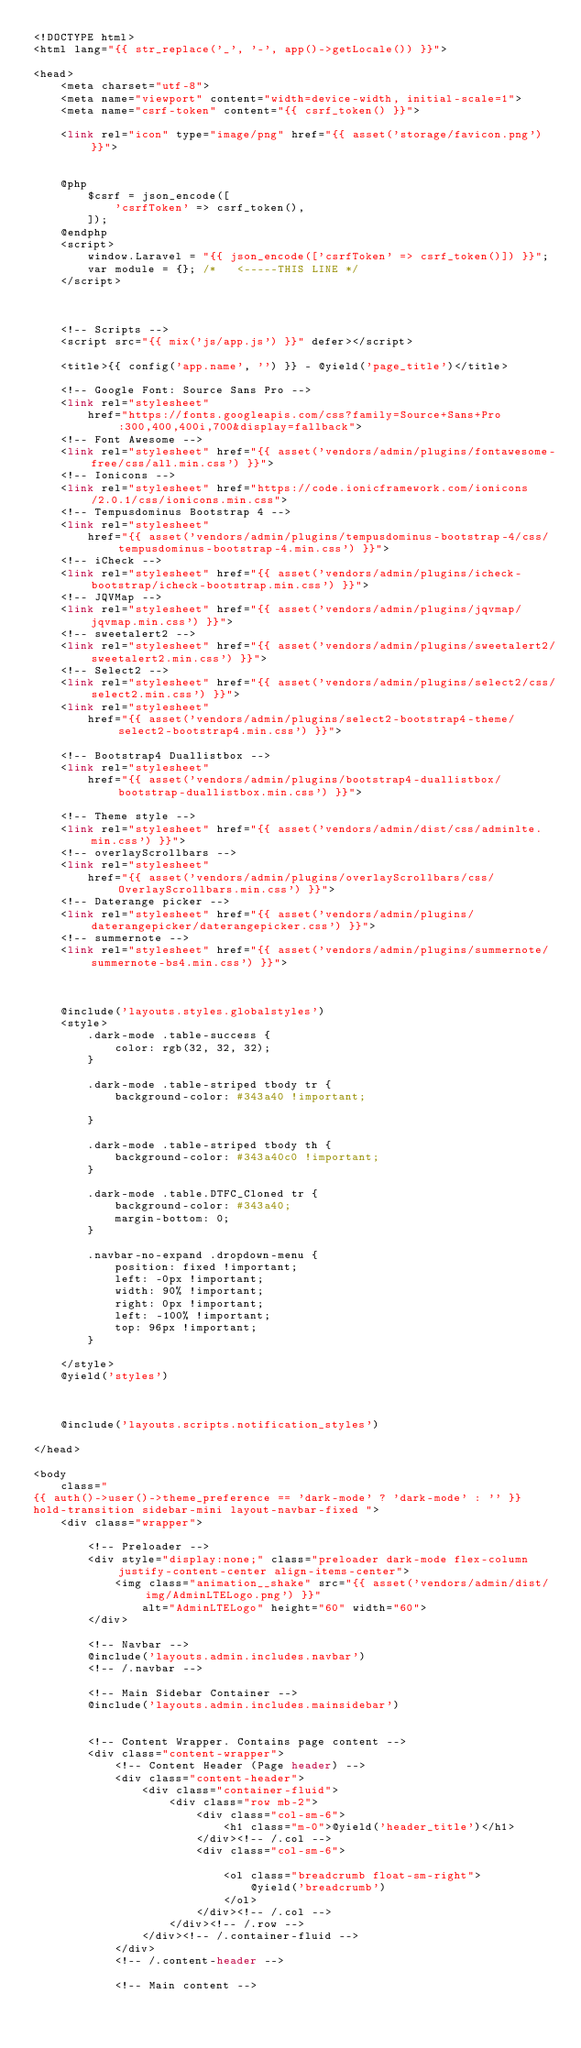Convert code to text. <code><loc_0><loc_0><loc_500><loc_500><_PHP_><!DOCTYPE html>
<html lang="{{ str_replace('_', '-', app()->getLocale()) }}">

<head>
    <meta charset="utf-8">
    <meta name="viewport" content="width=device-width, initial-scale=1">
    <meta name="csrf-token" content="{{ csrf_token() }}">

    <link rel="icon" type="image/png" href="{{ asset('storage/favicon.png') }}">


    @php
        $csrf = json_encode([
            'csrfToken' => csrf_token(),
        ]);
    @endphp
    <script>
        window.Laravel = "{{ json_encode(['csrfToken' => csrf_token()]) }}";
        var module = {}; /*   <-----THIS LINE */
    </script>



    <!-- Scripts -->
    <script src="{{ mix('js/app.js') }}" defer></script>

    <title>{{ config('app.name', '') }} - @yield('page_title')</title>

    <!-- Google Font: Source Sans Pro -->
    <link rel="stylesheet"
        href="https://fonts.googleapis.com/css?family=Source+Sans+Pro:300,400,400i,700&display=fallback">
    <!-- Font Awesome -->
    <link rel="stylesheet" href="{{ asset('vendors/admin/plugins/fontawesome-free/css/all.min.css') }}">
    <!-- Ionicons -->
    <link rel="stylesheet" href="https://code.ionicframework.com/ionicons/2.0.1/css/ionicons.min.css">
    <!-- Tempusdominus Bootstrap 4 -->
    <link rel="stylesheet"
        href="{{ asset('vendors/admin/plugins/tempusdominus-bootstrap-4/css/tempusdominus-bootstrap-4.min.css') }}">
    <!-- iCheck -->
    <link rel="stylesheet" href="{{ asset('vendors/admin/plugins/icheck-bootstrap/icheck-bootstrap.min.css') }}">
    <!-- JQVMap -->
    <link rel="stylesheet" href="{{ asset('vendors/admin/plugins/jqvmap/jqvmap.min.css') }}">
    <!-- sweetalert2 -->
    <link rel="stylesheet" href="{{ asset('vendors/admin/plugins/sweetalert2/sweetalert2.min.css') }}">
    <!-- Select2 -->
    <link rel="stylesheet" href="{{ asset('vendors/admin/plugins/select2/css/select2.min.css') }}">
    <link rel="stylesheet"
        href="{{ asset('vendors/admin/plugins/select2-bootstrap4-theme/select2-bootstrap4.min.css') }}">

    <!-- Bootstrap4 Duallistbox -->
    <link rel="stylesheet"
        href="{{ asset('vendors/admin/plugins/bootstrap4-duallistbox/bootstrap-duallistbox.min.css') }}">

    <!-- Theme style -->
    <link rel="stylesheet" href="{{ asset('vendors/admin/dist/css/adminlte.min.css') }}">
    <!-- overlayScrollbars -->
    <link rel="stylesheet"
        href="{{ asset('vendors/admin/plugins/overlayScrollbars/css/OverlayScrollbars.min.css') }}">
    <!-- Daterange picker -->
    <link rel="stylesheet" href="{{ asset('vendors/admin/plugins/daterangepicker/daterangepicker.css') }}">
    <!-- summernote -->
    <link rel="stylesheet" href="{{ asset('vendors/admin/plugins/summernote/summernote-bs4.min.css') }}">



    @include('layouts.styles.globalstyles')
    <style>
        .dark-mode .table-success {
            color: rgb(32, 32, 32);
        }

        .dark-mode .table-striped tbody tr {
            background-color: #343a40 !important;

        }

        .dark-mode .table-striped tbody th {
            background-color: #343a40c0 !important;
        }

        .dark-mode .table.DTFC_Cloned tr {
            background-color: #343a40;
            margin-bottom: 0;
        }

        .navbar-no-expand .dropdown-menu {
            position: fixed !important;
            left: -0px !important;
            width: 90% !important;
            right: 0px !important;
            left: -100% !important;
            top: 96px !important;
        }

    </style>
    @yield('styles')



    @include('layouts.scripts.notification_styles')

</head>

<body
    class="
{{ auth()->user()->theme_preference == 'dark-mode' ? 'dark-mode' : '' }}
hold-transition sidebar-mini layout-navbar-fixed ">
    <div class="wrapper">

        <!-- Preloader -->
        <div style="display:none;" class="preloader dark-mode flex-column justify-content-center align-items-center">
            <img class="animation__shake" src="{{ asset('vendors/admin/dist/img/AdminLTELogo.png') }}"
                alt="AdminLTELogo" height="60" width="60">
        </div>

        <!-- Navbar -->
        @include('layouts.admin.includes.navbar')
        <!-- /.navbar -->

        <!-- Main Sidebar Container -->
        @include('layouts.admin.includes.mainsidebar')


        <!-- Content Wrapper. Contains page content -->
        <div class="content-wrapper">
            <!-- Content Header (Page header) -->
            <div class="content-header">
                <div class="container-fluid">
                    <div class="row mb-2">
                        <div class="col-sm-6">
                            <h1 class="m-0">@yield('header_title')</h1>
                        </div><!-- /.col -->
                        <div class="col-sm-6">

                            <ol class="breadcrumb float-sm-right">
                                @yield('breadcrumb')
                            </ol>
                        </div><!-- /.col -->
                    </div><!-- /.row -->
                </div><!-- /.container-fluid -->
            </div>
            <!-- /.content-header -->

            <!-- Main content --></code> 